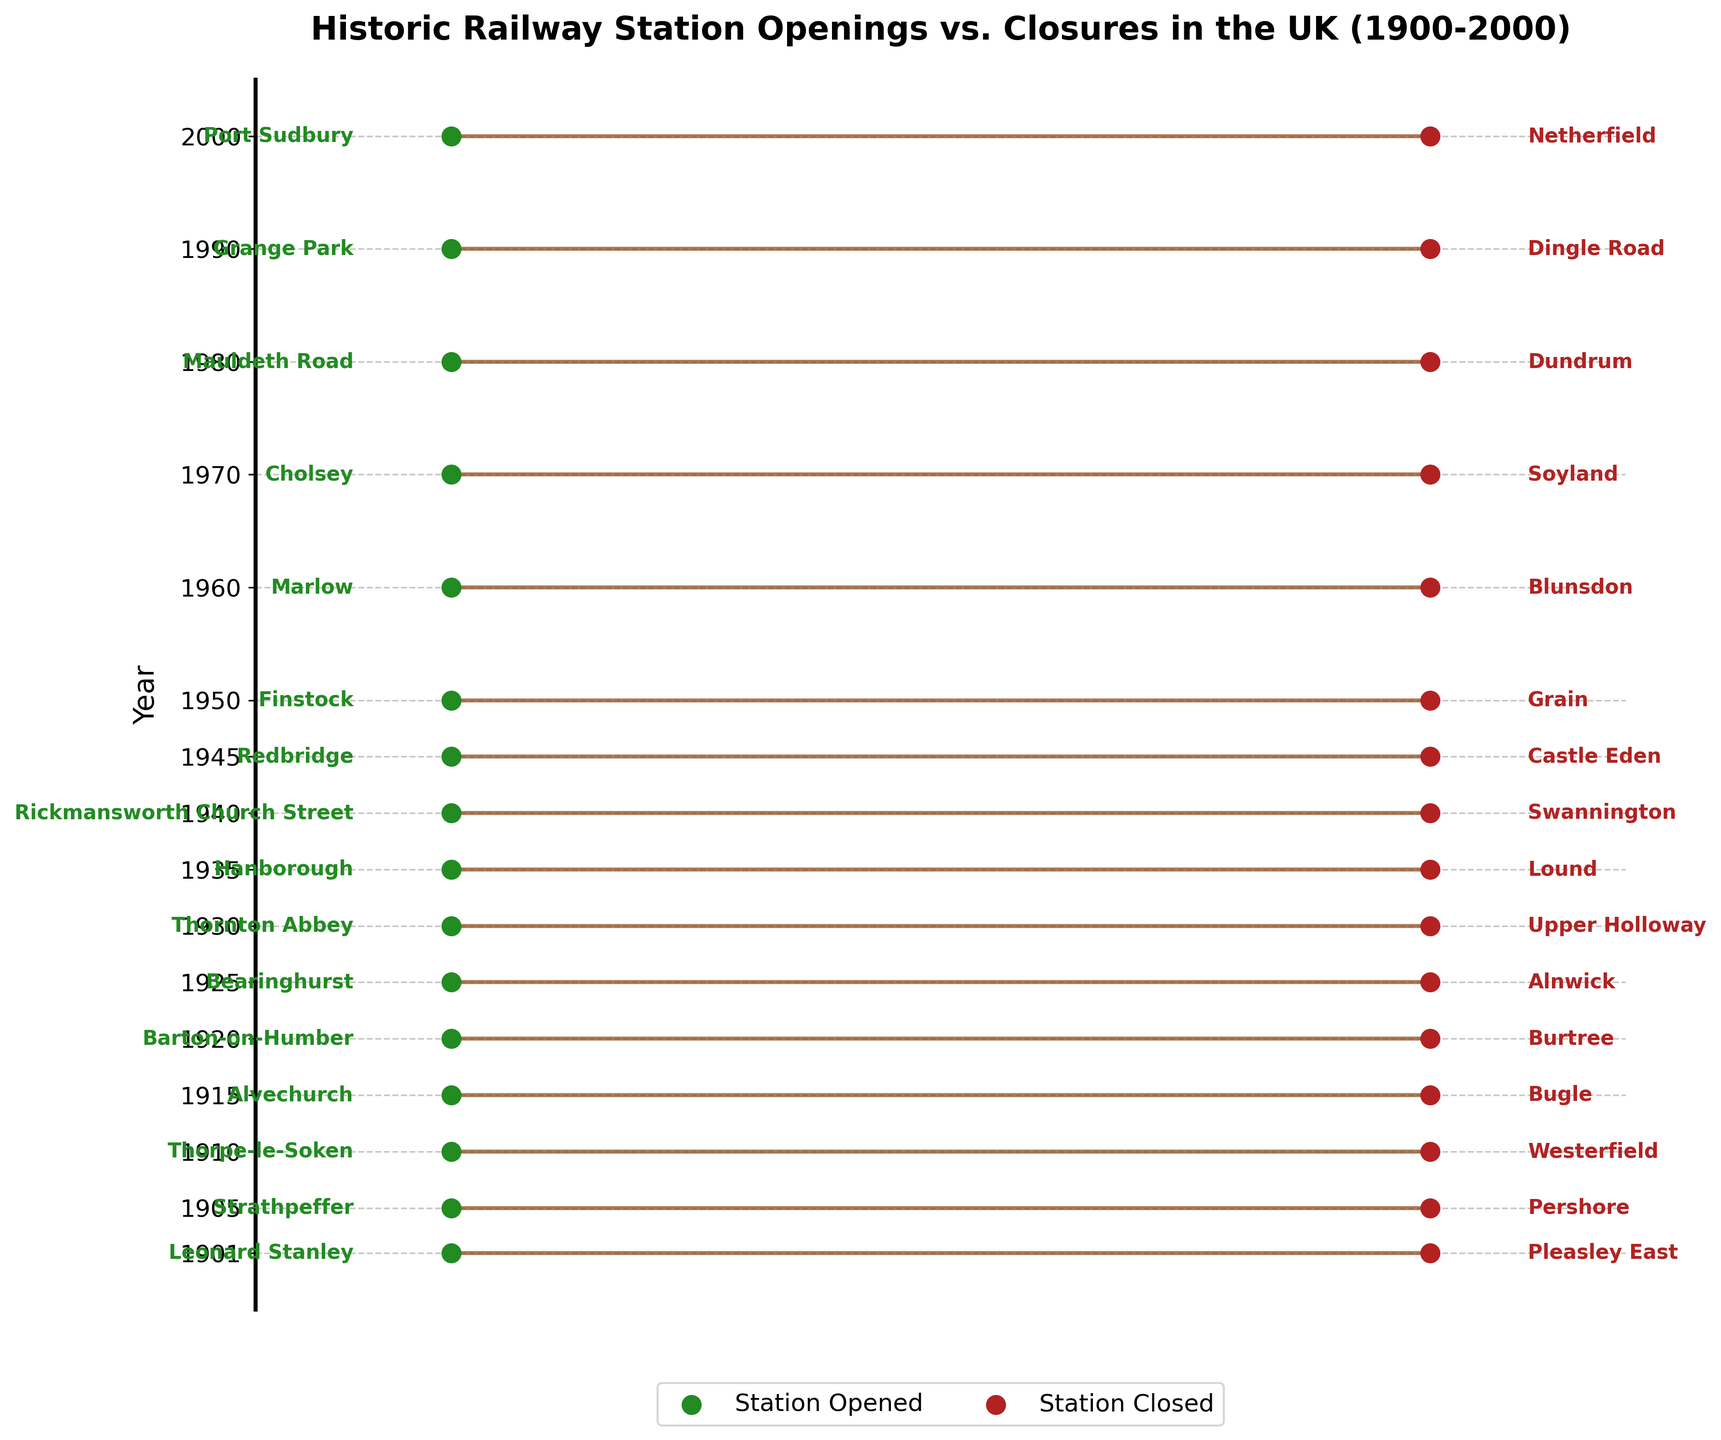what is the title of the plot? The title of the plot is at the top and reads 'Historic Railway Station Openings vs. Closures in the UK (1900-2000)'.
Answer: Historic Railway Station Openings vs. Closures in the UK (1900-2000) what color represents the stations that were opened? The stations that were opened are represented by green dots. The associated color legend next to 'Station Opened' also confirms this.
Answer: Green how many years are included in the plot? The plot has years shown on the y-axis as tick marks. Count the number of years listed. The data spans from 1901 to 2000 and includes 16 years.
Answer: 16 which station was closed in 1925? Locate the year 1925 on the y-axis, and look at the red label on the right side of that horizontal line. It reads 'Alnwick'.
Answer: Alnwick what year did the station Grange Park open? Find 'Grange Park' on the left side of the plot where the green labels are. Trace the horizontal line to the y-axis, which corresponds to the year 1990.
Answer: 1990 which station that closed is closest to its opening date in the plot? Compare the distance between dots on each horizontal line. The shortest appears between Mauldeth Road (opened 1980) and Dundrum (closed 1980). Check the spacing of all the year pairs.
Answer: Dundrum how many stations were opened between 1901 and 1950? Look at the years that fall between 1901 and 1950 in the data included in the plot, then count the number of green dots associated with those years.
Answer: 10 was there a year where a station was both opened and closed? Review each year to see if a green and red dot appear on the same horizontal line. This is the case for the year 1920, where Barton-on-Humber was opened, and Burtree was closed.
Answer: Yes which year had no station openings but saw a station closure? Search for a line without a green dot but with a red dot. In the provided data, 1901 is the only year like this, where Leonard Stanley was opened, and Pleasley East was closed.
Answer: 1901 